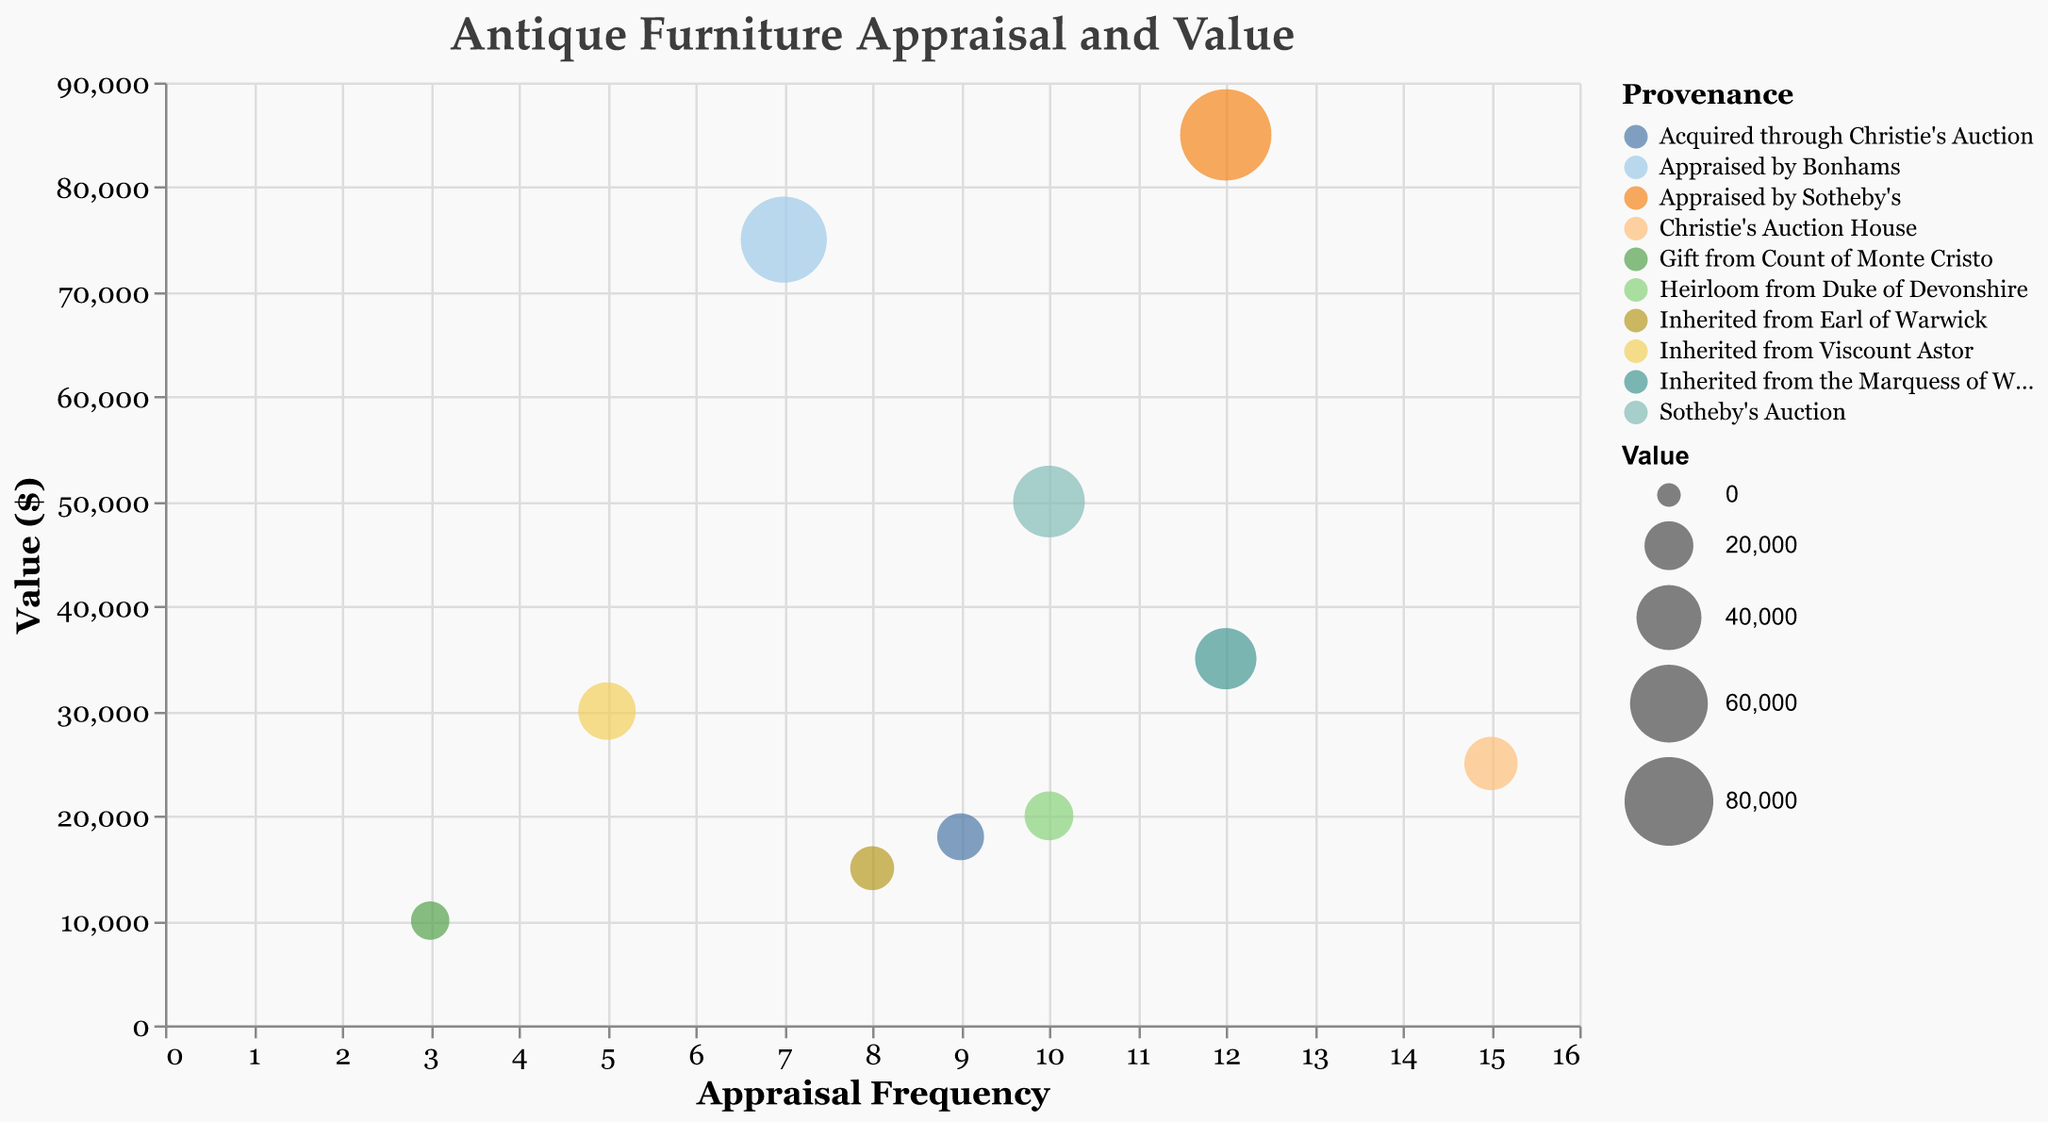How many antique items have an appraisal frequency of 12? To find this, look for the bubbles that are positioned at the 12 mark on the x-axis (Appraisal Frequency). There are two such items: "Victorian Walnut Sideboard" and "Ming Dynasty Table".
Answer: 2 Which item has the highest value? The highest value corresponds to the bubble with the highest y-axis position (Value). "Ming Dynasty Table" has the highest value of $85,000.
Answer: Ming Dynasty Table What is the total value of items appraised by Christie's Auction House? Identify all items with the provenance "Christie's Auction House". These are "George III Mahogany Chest" ($25,000) and "Georgian Oak Secretary" ($18,000). Sum their values: $25,000 + $18,000 = $43,000.
Answer: $43,000 Which provenance has the most frequently appraised item? Look for the bubble with the highest x-axis value (Appraisal Frequency of 15). This bubble corresponds to the provenance "Christie's Auction House" for the "George III Mahogany Chest".
Answer: Christie's Auction House Compare the values of the items inherited from nobility (Earl, Marquess, Viscount, Duke). Which has the highest value? The inherited items are: "Queen Anne Vanity" ($15,000), "Victorian Walnut Sideboard" ($35,000), "Art Deco Console Table" ($30,000), and "Edwardian Inlay Cabinet" ($20,000). The "Victorian Walnut Sideboard" has the highest value at $35,000.
Answer: Victorian Walnut Sideboard What is the average value of items that have been appraised 10 times? Only include items with an appraisal frequency of 10: "Chippendale Dining Table" ($50,000) and "Edwardian Inlay Cabinet" ($20,000). Average value = ($50,000 + $20,000) / 2 = $35,000.
Answer: $35,000 Which item from Sotheby's Auction has the highest value? There are two items from Sotheby's: "Chippendale Dining Table" ($50,000) and "Ming Dynasty Table" ($85,000). The highest value is $85,000 for "Ming Dynasty Table".
Answer: Ming Dynasty Table How many items originate from auction houses like Christie's or Sotheby's? Count the items with provenance "Christie's Auction House" or "Sotheby's Auction". There are 4 such items: "George III Mahogany Chest", "Georgian Oak Secretary", "Chippendale Dining Table", and "Ming Dynasty Table".
Answer: 4 Which item is the least frequently appraised? Identify the bubble with the lowest x-axis value (Appraisal Frequency of 3). This bubble corresponds to "Renaissance Revival Chair".
Answer: Renaissance Revival Chair What is the combined value of items sold through auction houses? Identify items from auction houses and sum their values: "George III Mahogany Chest" ($25,000), "Georgian Oak Secretary" ($18,000), "Chippendale Dining Table" ($50,000), and "Ming Dynasty Table" ($85,000). Combined value = $25,000 + $18,000 + $50,000 + $85,000 = $178,000.
Answer: $178,000 How many unique provenances are represented in the chart? Count distinct provenances: "Christie's Auction House", "Sotheby's Auction", "Inherited from Earl of Warwick", "Inherited from the Marquess of Winchester", "Appraised by Bonhams", "Heirloom from Duke of Devonshire", "Inherited from Viscount Astor", "Gift from Count of Monte Cristo". This totals 8 unique provenances.
Answer: 8 